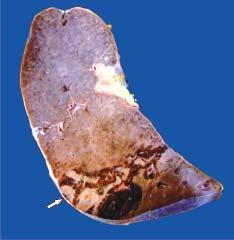where is base resting?
Answer the question using a single word or phrase. Under the capsule 